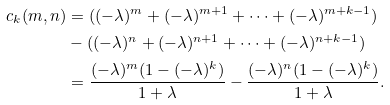<formula> <loc_0><loc_0><loc_500><loc_500>c _ { k } ( m , n ) & = ( ( - \lambda ) ^ { m } + ( - \lambda ) ^ { m + 1 } + \cdots + ( - \lambda ) ^ { m + k - 1 } ) \\ & - ( ( - \lambda ) ^ { n } + ( - \lambda ) ^ { n + 1 } + \cdots + ( - \lambda ) ^ { n + k - 1 } ) \\ & = \frac { ( - \lambda ) ^ { m } ( 1 - ( - \lambda ) ^ { k } ) } { 1 + \lambda } - \frac { ( - \lambda ) ^ { n } ( 1 - ( - \lambda ) ^ { k } ) } { 1 + \lambda } .</formula> 